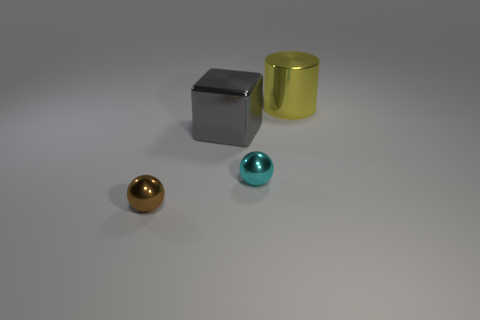Subtract 0 red blocks. How many objects are left? 4 Subtract all cylinders. How many objects are left? 3 Subtract 1 balls. How many balls are left? 1 Subtract all yellow cubes. Subtract all purple cylinders. How many cubes are left? 1 Subtract all yellow cylinders. How many purple cubes are left? 0 Subtract all large blocks. Subtract all tiny brown spheres. How many objects are left? 2 Add 3 yellow shiny things. How many yellow shiny things are left? 4 Add 4 large red metal balls. How many large red metal balls exist? 4 Add 1 blue metallic things. How many objects exist? 5 Subtract all cyan balls. How many balls are left? 1 